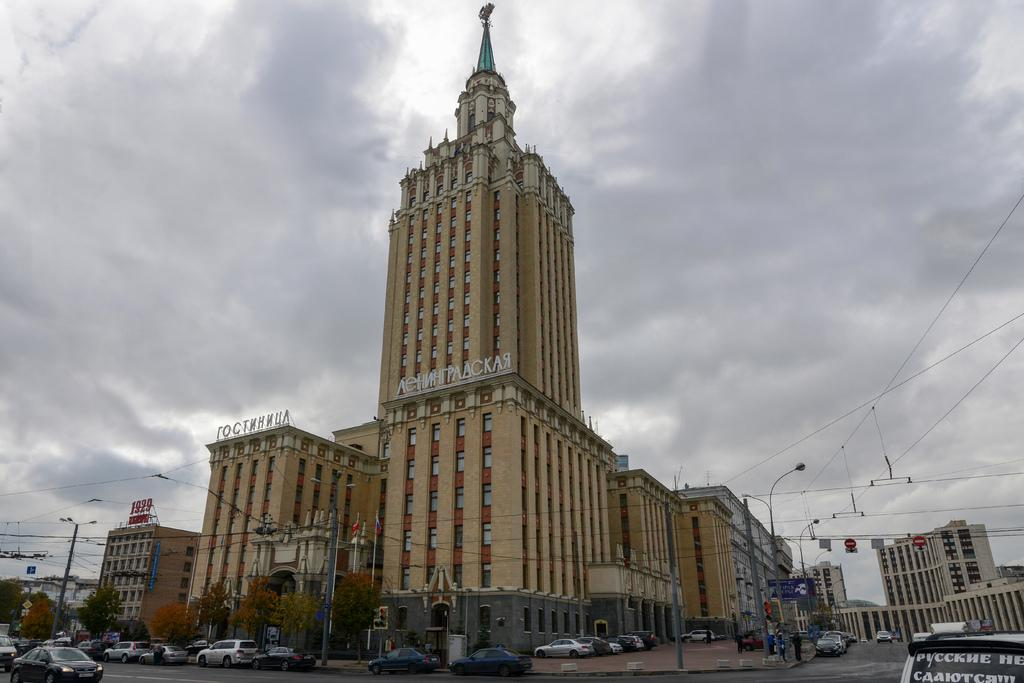What can be seen on the road in the image? There are vehicles on the road in the image. What else is present in the image besides the vehicles? There are many poles and buildings in the image. What is visible in the background of the image? There are clouds visible in the background of the image. Can you see any icicles hanging from the buildings in the image? There are no icicles present in the image; it appears to be a regular day with clouds in the background. What type of vegetable is being harvested in the image? There are no vegetables present in the image; it features vehicles on the road, poles, buildings, and clouds in the background. 